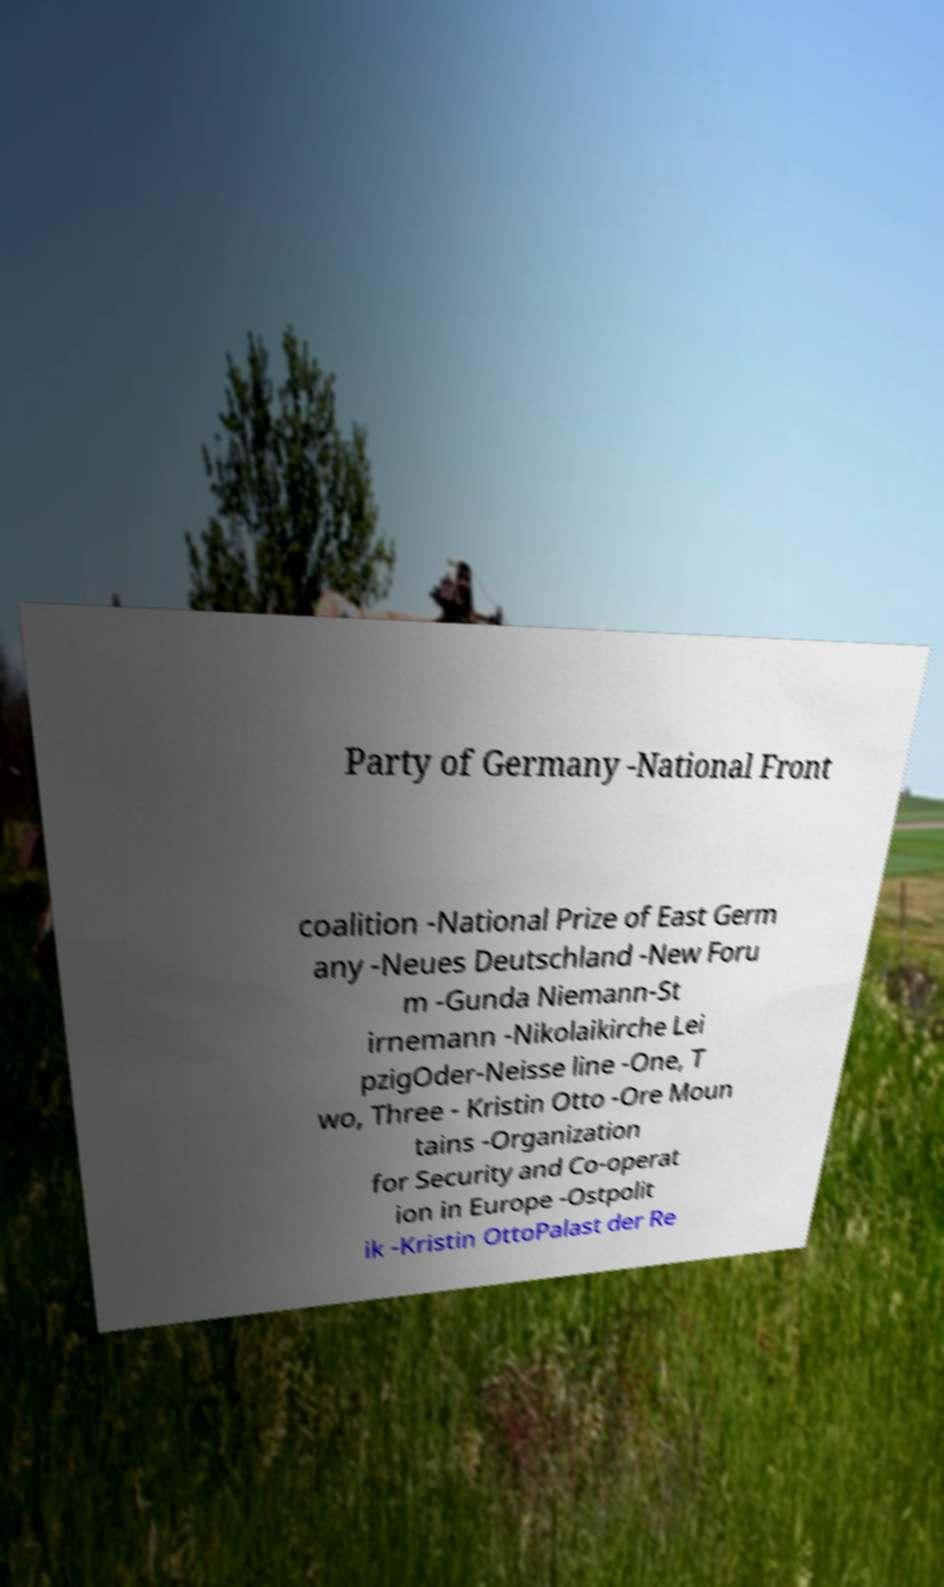I need the written content from this picture converted into text. Can you do that? Party of Germany -National Front coalition -National Prize of East Germ any -Neues Deutschland -New Foru m -Gunda Niemann-St irnemann -Nikolaikirche Lei pzigOder-Neisse line -One, T wo, Three - Kristin Otto -Ore Moun tains -Organization for Security and Co-operat ion in Europe -Ostpolit ik -Kristin OttoPalast der Re 